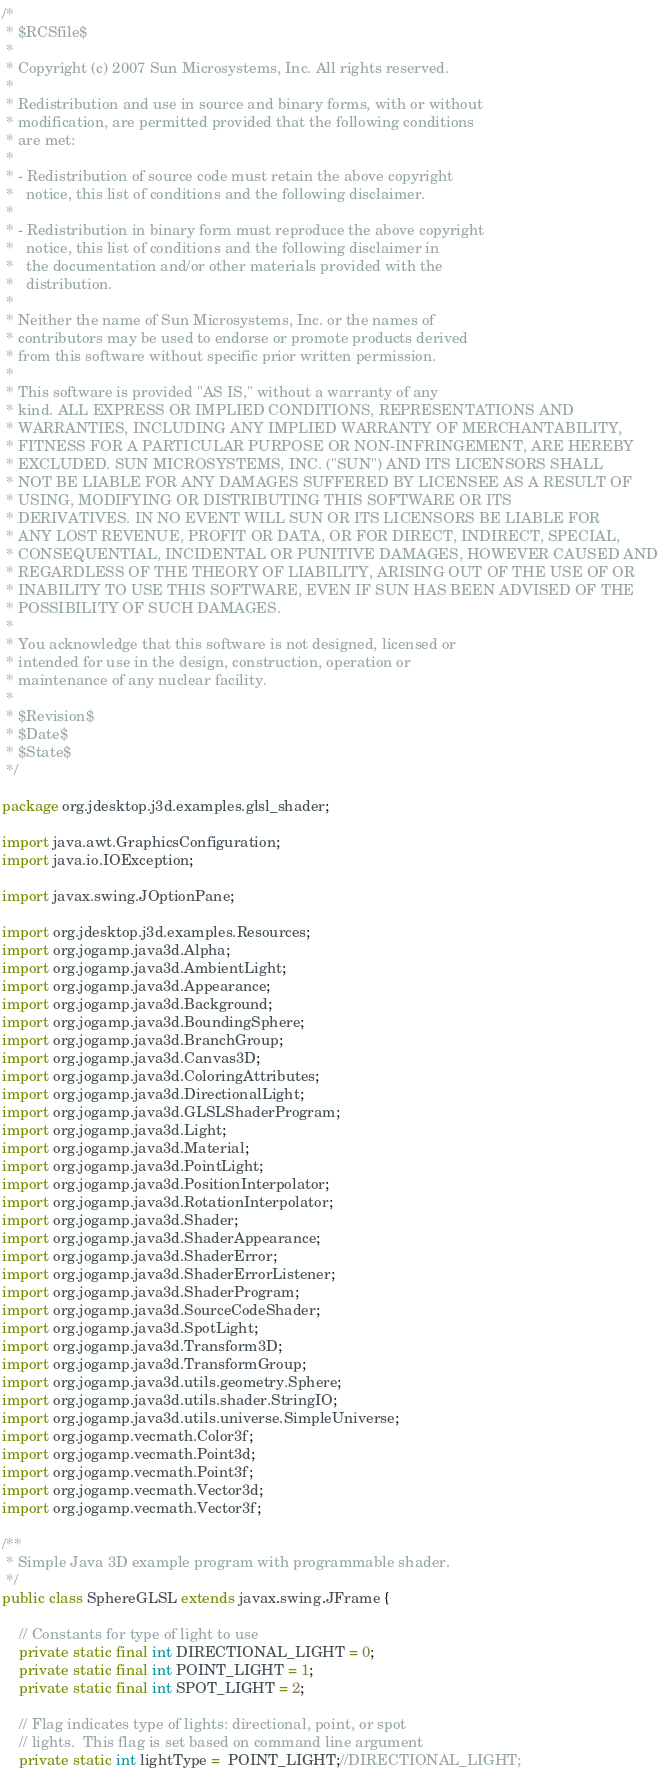Convert code to text. <code><loc_0><loc_0><loc_500><loc_500><_Java_>/*
 * $RCSfile$
 *
 * Copyright (c) 2007 Sun Microsystems, Inc. All rights reserved.
 *
 * Redistribution and use in source and binary forms, with or without
 * modification, are permitted provided that the following conditions
 * are met:
 *
 * - Redistribution of source code must retain the above copyright
 *   notice, this list of conditions and the following disclaimer.
 *
 * - Redistribution in binary form must reproduce the above copyright
 *   notice, this list of conditions and the following disclaimer in
 *   the documentation and/or other materials provided with the
 *   distribution.
 *
 * Neither the name of Sun Microsystems, Inc. or the names of
 * contributors may be used to endorse or promote products derived
 * from this software without specific prior written permission.
 *
 * This software is provided "AS IS," without a warranty of any
 * kind. ALL EXPRESS OR IMPLIED CONDITIONS, REPRESENTATIONS AND
 * WARRANTIES, INCLUDING ANY IMPLIED WARRANTY OF MERCHANTABILITY,
 * FITNESS FOR A PARTICULAR PURPOSE OR NON-INFRINGEMENT, ARE HEREBY
 * EXCLUDED. SUN MICROSYSTEMS, INC. ("SUN") AND ITS LICENSORS SHALL
 * NOT BE LIABLE FOR ANY DAMAGES SUFFERED BY LICENSEE AS A RESULT OF
 * USING, MODIFYING OR DISTRIBUTING THIS SOFTWARE OR ITS
 * DERIVATIVES. IN NO EVENT WILL SUN OR ITS LICENSORS BE LIABLE FOR
 * ANY LOST REVENUE, PROFIT OR DATA, OR FOR DIRECT, INDIRECT, SPECIAL,
 * CONSEQUENTIAL, INCIDENTAL OR PUNITIVE DAMAGES, HOWEVER CAUSED AND
 * REGARDLESS OF THE THEORY OF LIABILITY, ARISING OUT OF THE USE OF OR
 * INABILITY TO USE THIS SOFTWARE, EVEN IF SUN HAS BEEN ADVISED OF THE
 * POSSIBILITY OF SUCH DAMAGES.
 *
 * You acknowledge that this software is not designed, licensed or
 * intended for use in the design, construction, operation or
 * maintenance of any nuclear facility.
 *
 * $Revision$
 * $Date$
 * $State$
 */

package org.jdesktop.j3d.examples.glsl_shader;

import java.awt.GraphicsConfiguration;
import java.io.IOException;

import javax.swing.JOptionPane;

import org.jdesktop.j3d.examples.Resources;
import org.jogamp.java3d.Alpha;
import org.jogamp.java3d.AmbientLight;
import org.jogamp.java3d.Appearance;
import org.jogamp.java3d.Background;
import org.jogamp.java3d.BoundingSphere;
import org.jogamp.java3d.BranchGroup;
import org.jogamp.java3d.Canvas3D;
import org.jogamp.java3d.ColoringAttributes;
import org.jogamp.java3d.DirectionalLight;
import org.jogamp.java3d.GLSLShaderProgram;
import org.jogamp.java3d.Light;
import org.jogamp.java3d.Material;
import org.jogamp.java3d.PointLight;
import org.jogamp.java3d.PositionInterpolator;
import org.jogamp.java3d.RotationInterpolator;
import org.jogamp.java3d.Shader;
import org.jogamp.java3d.ShaderAppearance;
import org.jogamp.java3d.ShaderError;
import org.jogamp.java3d.ShaderErrorListener;
import org.jogamp.java3d.ShaderProgram;
import org.jogamp.java3d.SourceCodeShader;
import org.jogamp.java3d.SpotLight;
import org.jogamp.java3d.Transform3D;
import org.jogamp.java3d.TransformGroup;
import org.jogamp.java3d.utils.geometry.Sphere;
import org.jogamp.java3d.utils.shader.StringIO;
import org.jogamp.java3d.utils.universe.SimpleUniverse;
import org.jogamp.vecmath.Color3f;
import org.jogamp.vecmath.Point3d;
import org.jogamp.vecmath.Point3f;
import org.jogamp.vecmath.Vector3d;
import org.jogamp.vecmath.Vector3f;

/**
 * Simple Java 3D example program with programmable shader.
 */
public class SphereGLSL extends javax.swing.JFrame {

    // Constants for type of light to use
    private static final int DIRECTIONAL_LIGHT = 0;
    private static final int POINT_LIGHT = 1;
    private static final int SPOT_LIGHT = 2;

    // Flag indicates type of lights: directional, point, or spot
    // lights.  This flag is set based on command line argument
    private static int lightType =  POINT_LIGHT;//DIRECTIONAL_LIGHT;</code> 